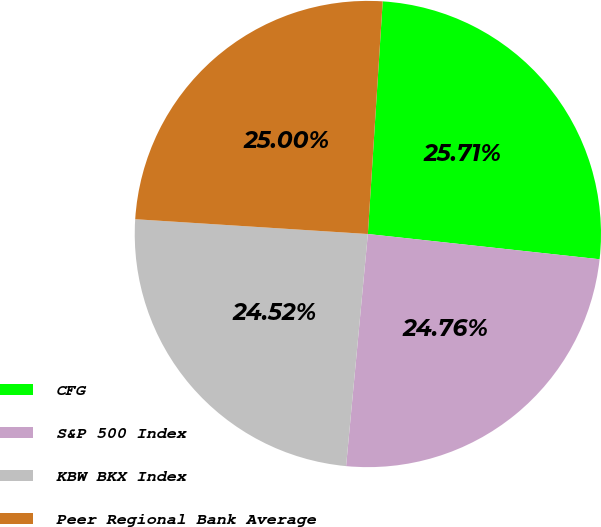Convert chart. <chart><loc_0><loc_0><loc_500><loc_500><pie_chart><fcel>CFG<fcel>S&P 500 Index<fcel>KBW BKX Index<fcel>Peer Regional Bank Average<nl><fcel>25.71%<fcel>24.76%<fcel>24.52%<fcel>25.0%<nl></chart> 